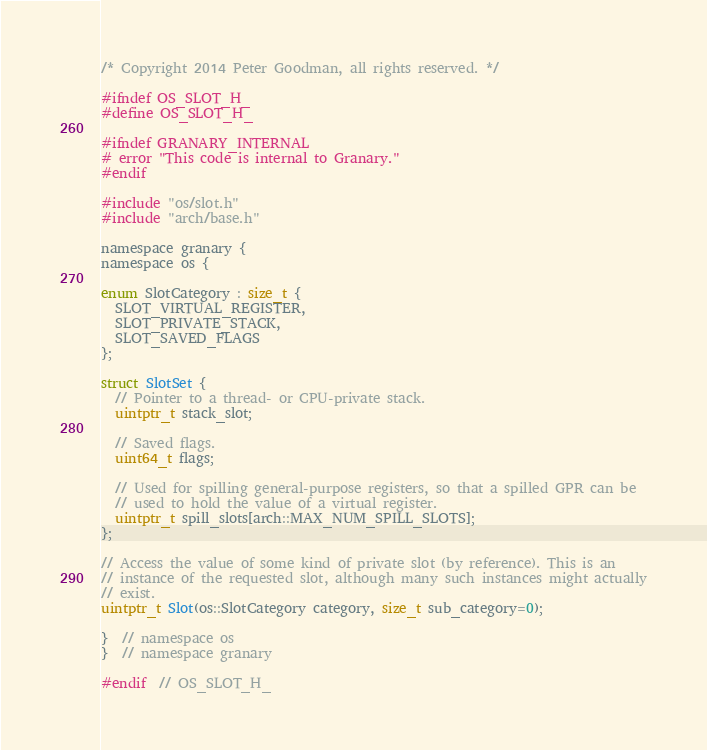Convert code to text. <code><loc_0><loc_0><loc_500><loc_500><_C_>/* Copyright 2014 Peter Goodman, all rights reserved. */

#ifndef OS_SLOT_H_
#define OS_SLOT_H_

#ifndef GRANARY_INTERNAL
# error "This code is internal to Granary."
#endif

#include "os/slot.h"
#include "arch/base.h"

namespace granary {
namespace os {

enum SlotCategory : size_t {
  SLOT_VIRTUAL_REGISTER,
  SLOT_PRIVATE_STACK,
  SLOT_SAVED_FLAGS
};

struct SlotSet {
  // Pointer to a thread- or CPU-private stack.
  uintptr_t stack_slot;

  // Saved flags.
  uint64_t flags;

  // Used for spilling general-purpose registers, so that a spilled GPR can be
  // used to hold the value of a virtual register.
  uintptr_t spill_slots[arch::MAX_NUM_SPILL_SLOTS];
};

// Access the value of some kind of private slot (by reference). This is an
// instance of the requested slot, although many such instances might actually
// exist.
uintptr_t Slot(os::SlotCategory category, size_t sub_category=0);

}  // namespace os
}  // namespace granary

#endif  // OS_SLOT_H_
</code> 